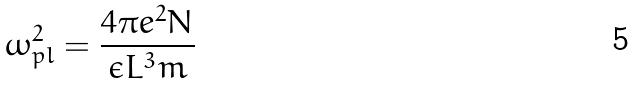<formula> <loc_0><loc_0><loc_500><loc_500>\omega _ { p l } ^ { 2 } = \frac { 4 \pi e ^ { 2 } N } { \epsilon L ^ { 3 } m }</formula> 